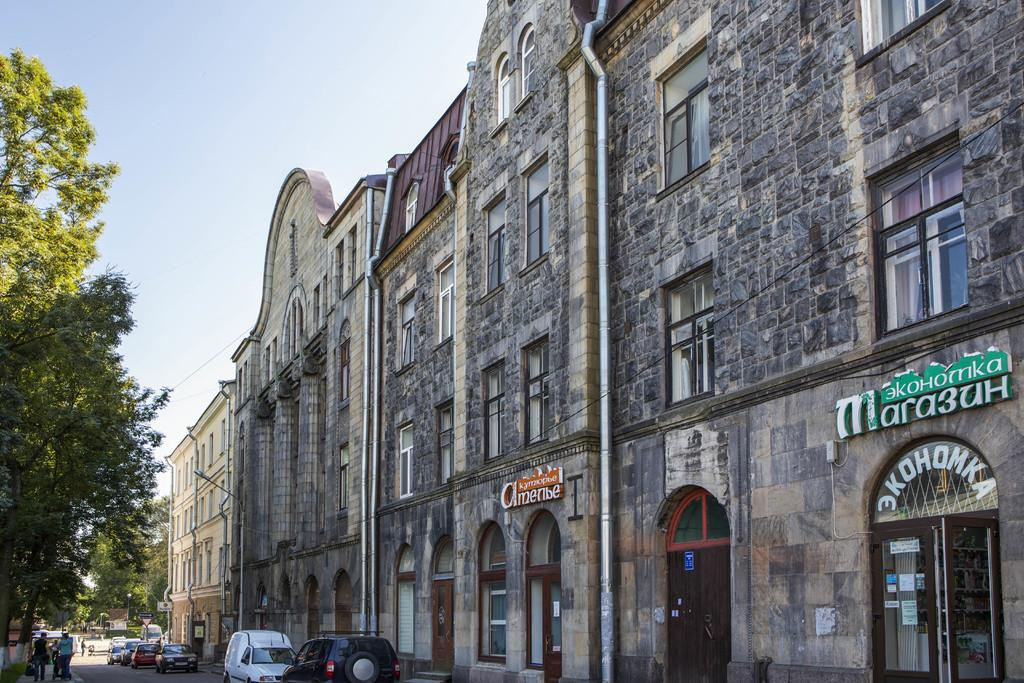What can be seen on the road in the image? There are vehicles on the road in the image. Who or what is present in the image besides the vehicles? There are persons, trees, boards, doors, windows, and buildings in the image. Can you describe the buildings in the image? The buildings in the image have doors and windows. What is visible in the background of the image? The sky is visible in the background of the image. What type of store can be seen in the image? There is no store present in the image. How does the feeling of the image change when the act of walking is introduced? The image does not convey a feeling, and there is no act of walking mentioned in the image. 